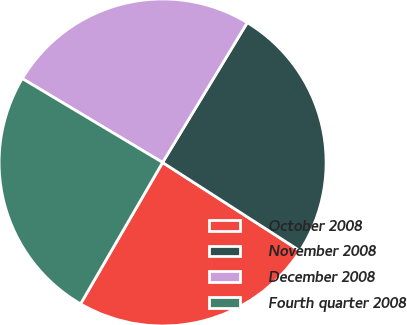<chart> <loc_0><loc_0><loc_500><loc_500><pie_chart><fcel>October 2008<fcel>November 2008<fcel>December 2008<fcel>Fourth quarter 2008<nl><fcel>24.27%<fcel>25.43%<fcel>25.09%<fcel>25.21%<nl></chart> 